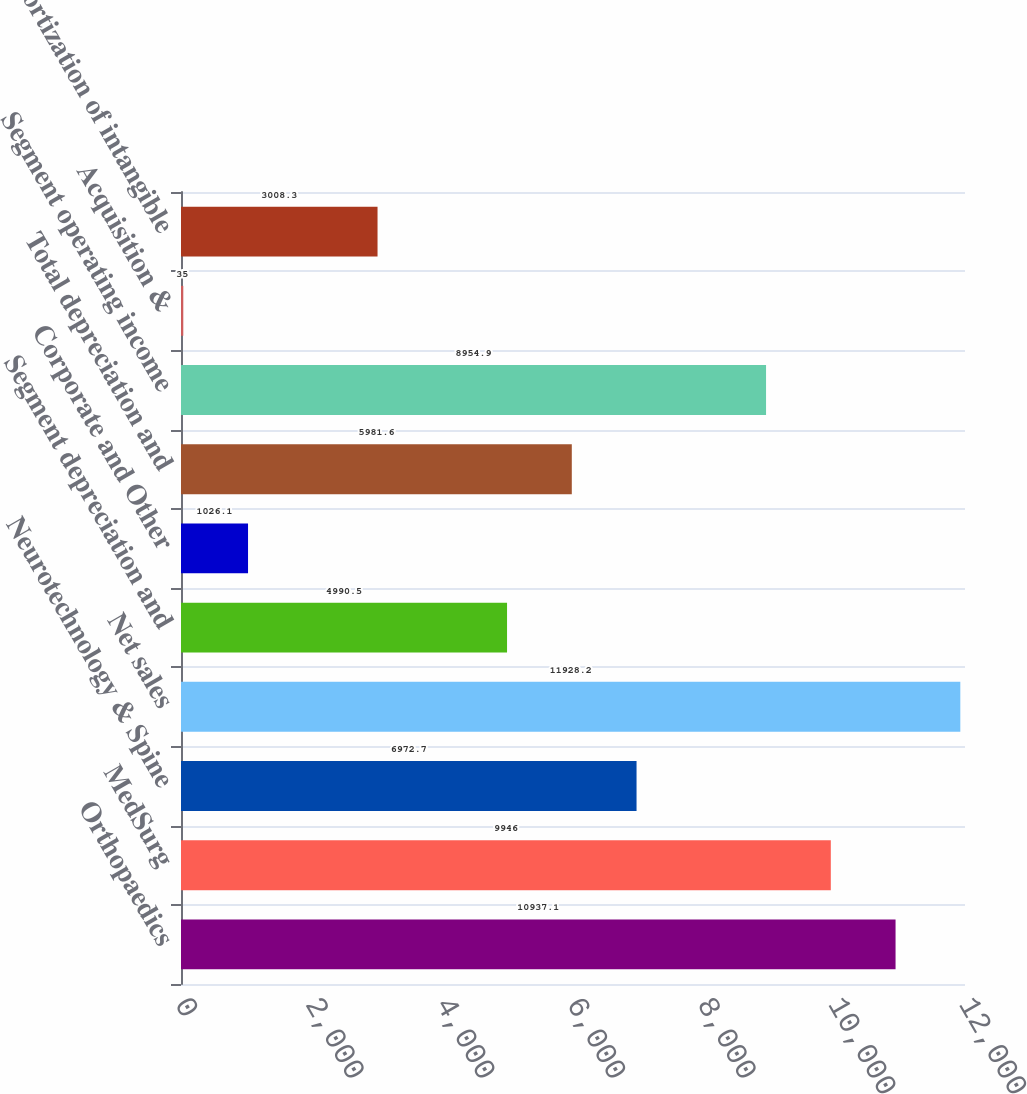Convert chart. <chart><loc_0><loc_0><loc_500><loc_500><bar_chart><fcel>Orthopaedics<fcel>MedSurg<fcel>Neurotechnology & Spine<fcel>Net sales<fcel>Segment depreciation and<fcel>Corporate and Other<fcel>Total depreciation and<fcel>Segment operating income<fcel>Acquisition &<fcel>Amortization of intangible<nl><fcel>10937.1<fcel>9946<fcel>6972.7<fcel>11928.2<fcel>4990.5<fcel>1026.1<fcel>5981.6<fcel>8954.9<fcel>35<fcel>3008.3<nl></chart> 